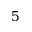<formula> <loc_0><loc_0><loc_500><loc_500>5</formula> 